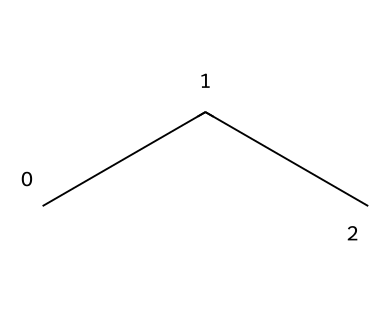What is the name of this chemical? The SMILES representation "CCC" indicates a linear chain of three carbon atoms with associated hydrogen atoms. This structure corresponds to propane, which is a common aliphatic hydrocarbon.
Answer: propane How many carbon atoms are in this molecule? The SMILES "CCC" shows three contiguous carbon atoms in the structure. Therefore, there are three carbon atoms.
Answer: three What is the molecular formula of propane? Each carbon atom in propane can bond with three hydrogen atoms, resulting in two hydrogen atoms for the terminal carbons and one hydrogen atom for the central carbon, giving the formula C3H8.
Answer: C3H8 What type of chemical bonding is present in propane? The structure "CCC" shows single bonds connecting the carbon atoms, characteristic of aliphatic compounds, indicating that propane is solely connected through sigma bonds.
Answer: single bonds Is propane a saturated or unsaturated hydrocarbon? Since all carbon atoms in propane utilize single bonds and contain the maximum number of hydrogen atoms, it qualifies as a saturated hydrocarbon.
Answer: saturated How many hydrogen atoms are connected to each carbon in propane? Each terminal carbon (two in total) is connected to three hydrogen atoms, and the middle carbon is connected to two, totaling eight hydrogen atoms in the molecule.
Answer: eight What is the significance of propane in residential heating? Propane is a common fuel used for residential heating due to its high energy content, ease of transport, and clean combustion properties, which makes it suitable for heating applications.
Answer: energy source 